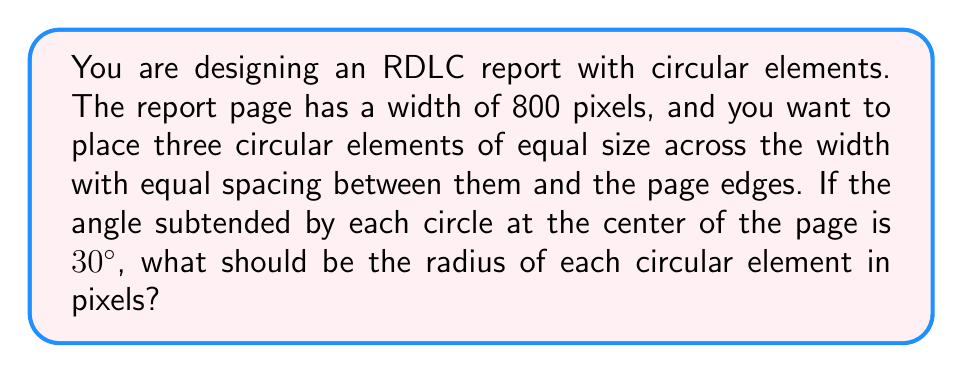What is the answer to this math problem? Let's approach this step-by-step:

1) First, we need to understand the layout. We have three circles across the width of 800 pixels, with equal spacing between them and the edges.

2) The angle subtended by each circle at the center of the page is 30°. This means that the three circles together subtend an angle of 90° (3 * 30°).

3) We can divide the page width into two equal halves of 400 pixels each. Let's focus on one half.

4) In this half, we have 1.5 circles (half of the middle circle and one full outer circle) and two spaces (one between the circles and one at the edge).

5) Let's draw a right-angled triangle from the center of the page to the edge of an outer circle:

   [asy]
   import geometry;
   
   size(200);
   pair O=(0,0), A=(8,0), B=(8,4.6188);
   draw(O--A--B--O);
   draw(arc(O,8,0,30));
   label("O",O,SW);
   label("A",A,SE);
   label("B",B,NE);
   label("r",(.5*(O+B)),W);
   label("400",(.5*(O+A)),S);
   label("30°",(1,0.5),E);
   [/asy]

6) In this triangle:
   - The hypotenuse (OB) is 400 pixels (half the page width)
   - The angle at O is 15° (half of 30°)
   - We need to find the length of OB, which is the radius (r) of the circle

7) We can use the cosine function:

   $$ \cos 15° = \frac{r}{400} $$

8) Solving for r:

   $$ r = 400 \cos 15° $$

9) $\cos 15° \approx 0.9659$

10) Therefore:

    $$ r \approx 400 * 0.9659 \approx 386.36 \text{ pixels} $$
Answer: The radius of each circular element should be approximately 386.36 pixels. 